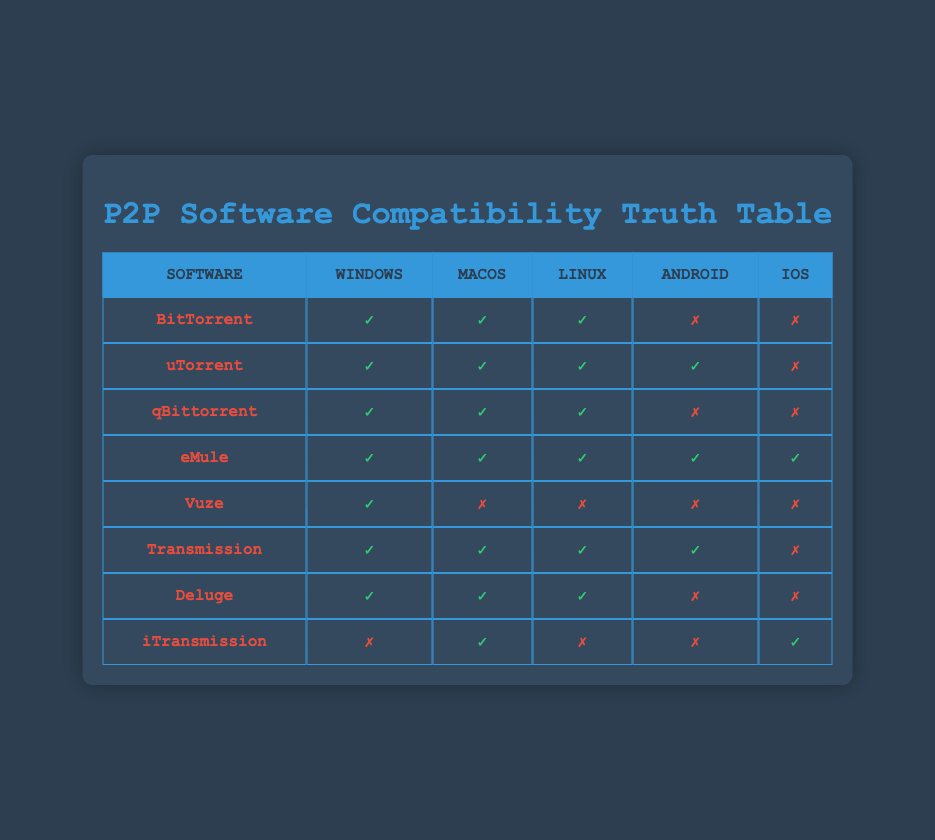What P2P software is compatible with iOS? Looking at the table, iOS has compatibility for only one software, which is iTransmission. All other software entries have a false status under the iOS column.
Answer: iTransmission Which P2P software is not compatible with Android? In the Android column, we can see that BitTorrent, qBittorrent, and Deluge have a false status, indicating they are not compatible with Android.
Answer: BitTorrent, qBittorrent, Deluge How many P2P software are compatible with all five operating systems? From the table, only eMule has a true status for every operating system listed, meaning it is compatible with all of them.
Answer: 1 Is uTorrent compatible with Linux? Referring to the table, the Linux column for uTorrent has a true status, meaning it is indeed compatible with Linux.
Answer: Yes Which operating system has the most P2P software compatibility based on the table? By assessing the columns, both Windows and macOS show compatibility with all eight software listed, while iOS is least compatible, confirming Windows and macOS have the most.
Answer: Windows, macOS Which software has the least compatibility across all operating systems? Reviewing the table, Vuze has compatibility only with Windows, showing a total of one operating system it works with, making it the least compatible.
Answer: Vuze How many P2P software are compatible with both Windows and Android? Analyzing the table, we see uTorrent and eMule are the only software instances where both Windows and Android columns have a true status. Therefore, we find a total of two software that meet this criterion.
Answer: 2 Is there any P2P software available for both Android and iOS? In checking the columns for both Android and iOS, we find no software that has a true status in both columns, indicating none are available for both platforms.
Answer: No 